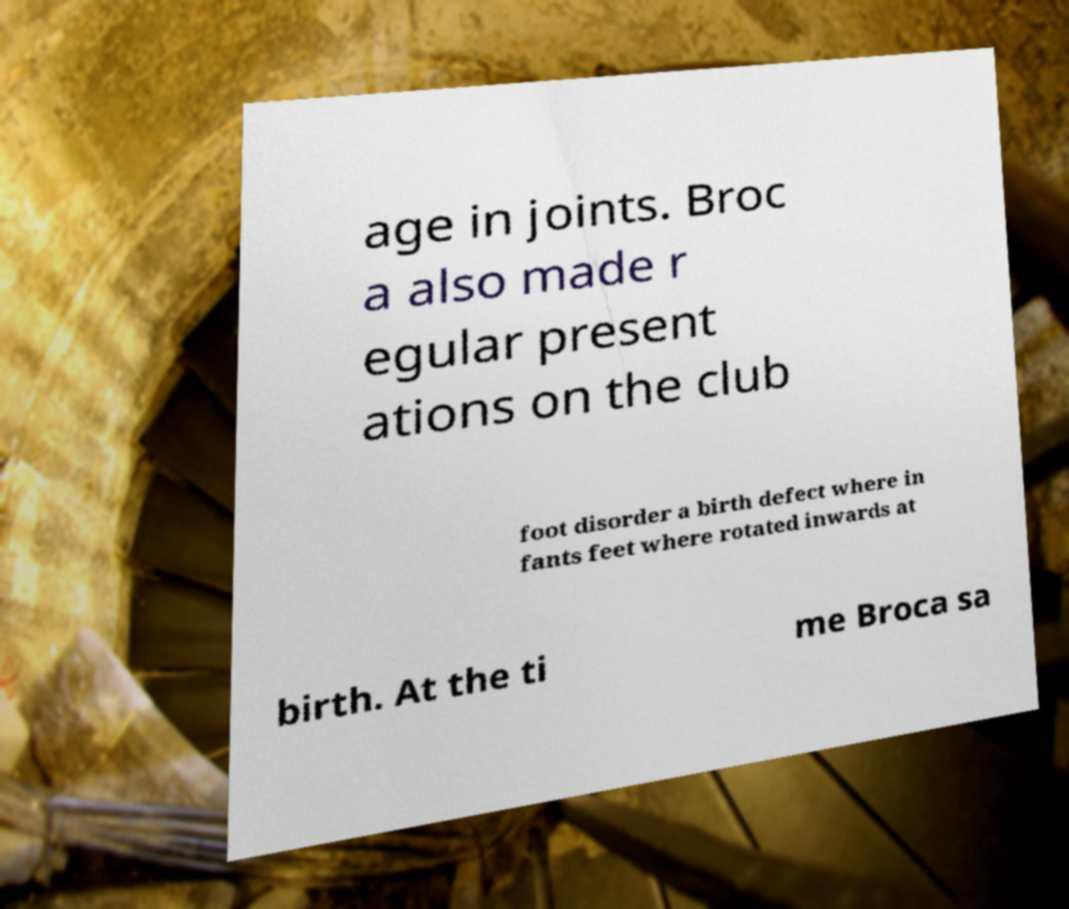What messages or text are displayed in this image? I need them in a readable, typed format. age in joints. Broc a also made r egular present ations on the club foot disorder a birth defect where in fants feet where rotated inwards at birth. At the ti me Broca sa 